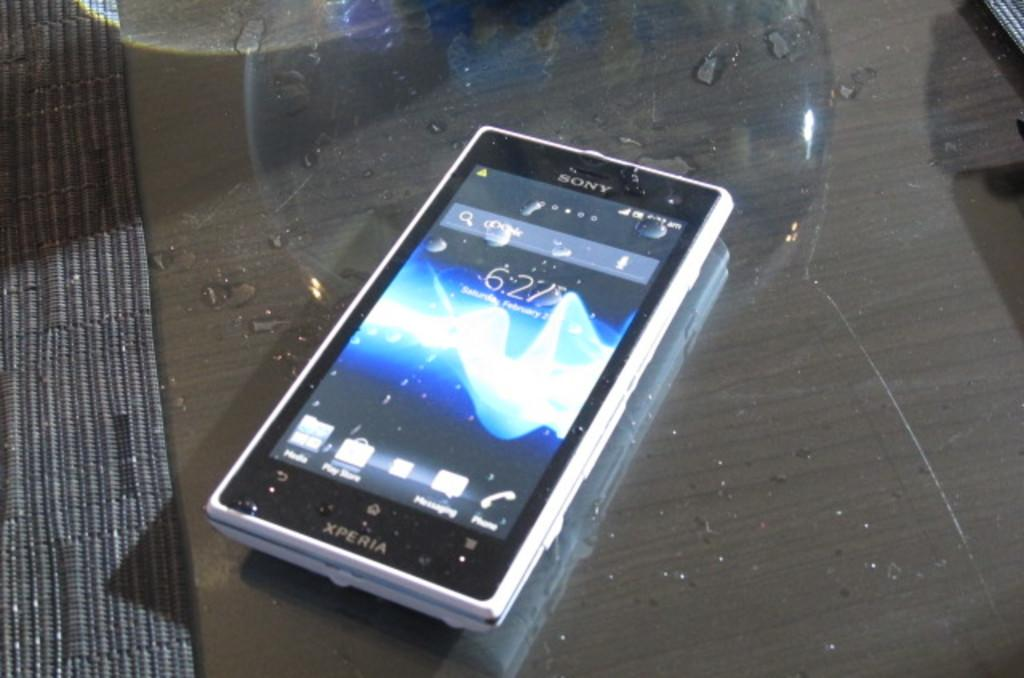What electronic device is visible in the image? There is a mobile phone in the image. Which company manufactures the mobile phone? The mobile phone is of Sony company. On what surface is the mobile phone placed? The mobile phone is on a glass table. Can you see a tiger walking in the shade in the image? No, there is no tiger or shade present in the image. 